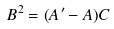Convert formula to latex. <formula><loc_0><loc_0><loc_500><loc_500>B ^ { 2 } = ( A ^ { \prime } - A ) C</formula> 